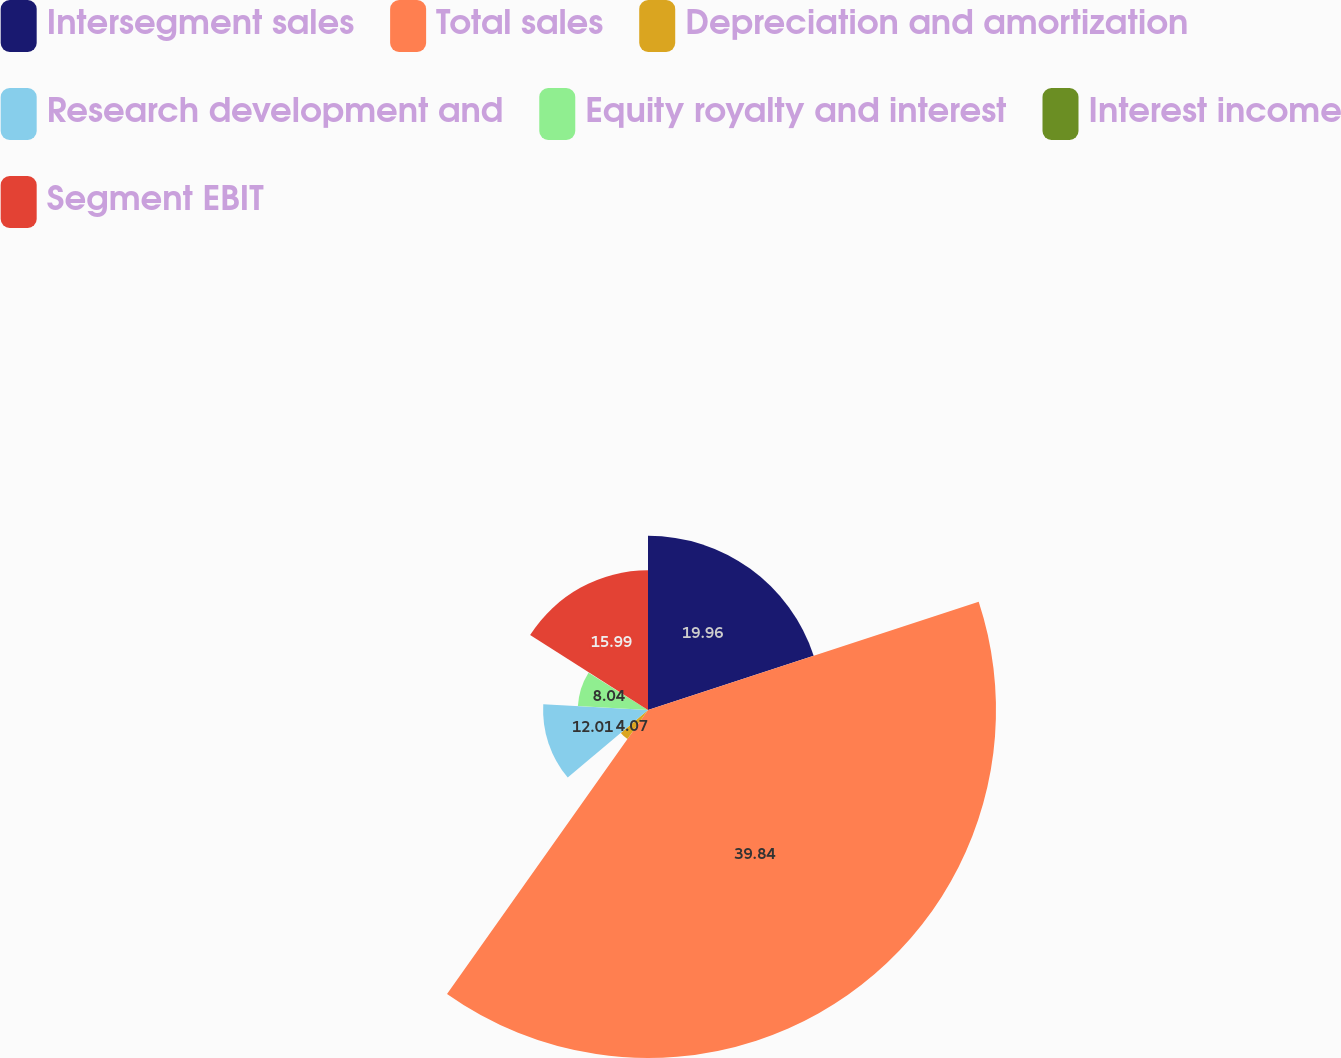<chart> <loc_0><loc_0><loc_500><loc_500><pie_chart><fcel>Intersegment sales<fcel>Total sales<fcel>Depreciation and amortization<fcel>Research development and<fcel>Equity royalty and interest<fcel>Interest income<fcel>Segment EBIT<nl><fcel>19.96%<fcel>39.84%<fcel>4.07%<fcel>12.01%<fcel>8.04%<fcel>0.09%<fcel>15.99%<nl></chart> 